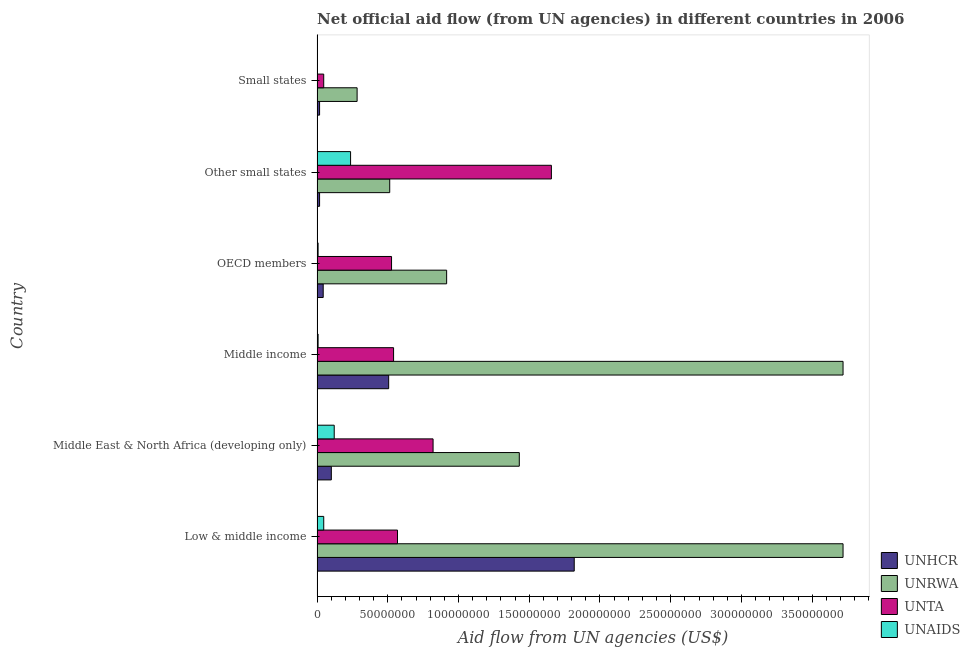How many groups of bars are there?
Keep it short and to the point. 6. Are the number of bars per tick equal to the number of legend labels?
Keep it short and to the point. Yes. How many bars are there on the 2nd tick from the bottom?
Your response must be concise. 4. What is the label of the 1st group of bars from the top?
Provide a short and direct response. Small states. What is the amount of aid given by unta in Small states?
Your answer should be very brief. 4.71e+06. Across all countries, what is the maximum amount of aid given by unhcr?
Provide a short and direct response. 1.82e+08. Across all countries, what is the minimum amount of aid given by unrwa?
Provide a succinct answer. 2.83e+07. In which country was the amount of aid given by unta maximum?
Make the answer very short. Other small states. In which country was the amount of aid given by unta minimum?
Your response must be concise. Small states. What is the total amount of aid given by unhcr in the graph?
Make the answer very short. 2.50e+08. What is the difference between the amount of aid given by unrwa in Low & middle income and that in Other small states?
Ensure brevity in your answer.  3.20e+08. What is the difference between the amount of aid given by unta in Middle income and the amount of aid given by unaids in Middle East & North Africa (developing only)?
Your answer should be very brief. 4.20e+07. What is the average amount of aid given by unta per country?
Provide a short and direct response. 6.93e+07. What is the difference between the amount of aid given by unhcr and amount of aid given by unaids in Low & middle income?
Keep it short and to the point. 1.77e+08. In how many countries, is the amount of aid given by unrwa greater than 170000000 US$?
Offer a terse response. 2. What is the ratio of the amount of aid given by unhcr in Low & middle income to that in OECD members?
Keep it short and to the point. 41.79. What is the difference between the highest and the second highest amount of aid given by unta?
Ensure brevity in your answer.  8.36e+07. What is the difference between the highest and the lowest amount of aid given by unta?
Offer a terse response. 1.61e+08. In how many countries, is the amount of aid given by unhcr greater than the average amount of aid given by unhcr taken over all countries?
Your answer should be compact. 2. Is the sum of the amount of aid given by unta in Middle East & North Africa (developing only) and Middle income greater than the maximum amount of aid given by unaids across all countries?
Provide a short and direct response. Yes. What does the 4th bar from the top in OECD members represents?
Make the answer very short. UNHCR. What does the 4th bar from the bottom in OECD members represents?
Your response must be concise. UNAIDS. Is it the case that in every country, the sum of the amount of aid given by unhcr and amount of aid given by unrwa is greater than the amount of aid given by unta?
Make the answer very short. No. How many bars are there?
Give a very brief answer. 24. Are all the bars in the graph horizontal?
Provide a succinct answer. Yes. How many countries are there in the graph?
Offer a very short reply. 6. Does the graph contain any zero values?
Provide a succinct answer. No. Does the graph contain grids?
Keep it short and to the point. No. What is the title of the graph?
Your answer should be very brief. Net official aid flow (from UN agencies) in different countries in 2006. Does "Denmark" appear as one of the legend labels in the graph?
Keep it short and to the point. No. What is the label or title of the X-axis?
Make the answer very short. Aid flow from UN agencies (US$). What is the Aid flow from UN agencies (US$) of UNHCR in Low & middle income?
Offer a terse response. 1.82e+08. What is the Aid flow from UN agencies (US$) in UNRWA in Low & middle income?
Provide a short and direct response. 3.72e+08. What is the Aid flow from UN agencies (US$) of UNTA in Low & middle income?
Keep it short and to the point. 5.69e+07. What is the Aid flow from UN agencies (US$) of UNAIDS in Low & middle income?
Offer a very short reply. 4.72e+06. What is the Aid flow from UN agencies (US$) of UNHCR in Middle East & North Africa (developing only)?
Ensure brevity in your answer.  1.01e+07. What is the Aid flow from UN agencies (US$) of UNRWA in Middle East & North Africa (developing only)?
Offer a terse response. 1.43e+08. What is the Aid flow from UN agencies (US$) of UNTA in Middle East & North Africa (developing only)?
Your answer should be very brief. 8.20e+07. What is the Aid flow from UN agencies (US$) of UNAIDS in Middle East & North Africa (developing only)?
Provide a short and direct response. 1.21e+07. What is the Aid flow from UN agencies (US$) of UNHCR in Middle income?
Make the answer very short. 5.06e+07. What is the Aid flow from UN agencies (US$) of UNRWA in Middle income?
Offer a very short reply. 3.72e+08. What is the Aid flow from UN agencies (US$) of UNTA in Middle income?
Make the answer very short. 5.41e+07. What is the Aid flow from UN agencies (US$) of UNAIDS in Middle income?
Make the answer very short. 7.40e+05. What is the Aid flow from UN agencies (US$) of UNHCR in OECD members?
Your response must be concise. 4.35e+06. What is the Aid flow from UN agencies (US$) in UNRWA in OECD members?
Ensure brevity in your answer.  9.16e+07. What is the Aid flow from UN agencies (US$) in UNTA in OECD members?
Give a very brief answer. 5.27e+07. What is the Aid flow from UN agencies (US$) in UNAIDS in OECD members?
Make the answer very short. 7.40e+05. What is the Aid flow from UN agencies (US$) in UNHCR in Other small states?
Provide a succinct answer. 1.78e+06. What is the Aid flow from UN agencies (US$) of UNRWA in Other small states?
Give a very brief answer. 5.14e+07. What is the Aid flow from UN agencies (US$) of UNTA in Other small states?
Offer a very short reply. 1.66e+08. What is the Aid flow from UN agencies (US$) of UNAIDS in Other small states?
Provide a succinct answer. 2.37e+07. What is the Aid flow from UN agencies (US$) in UNHCR in Small states?
Offer a very short reply. 1.78e+06. What is the Aid flow from UN agencies (US$) in UNRWA in Small states?
Keep it short and to the point. 2.83e+07. What is the Aid flow from UN agencies (US$) of UNTA in Small states?
Your answer should be compact. 4.71e+06. Across all countries, what is the maximum Aid flow from UN agencies (US$) in UNHCR?
Keep it short and to the point. 1.82e+08. Across all countries, what is the maximum Aid flow from UN agencies (US$) in UNRWA?
Give a very brief answer. 3.72e+08. Across all countries, what is the maximum Aid flow from UN agencies (US$) of UNTA?
Offer a very short reply. 1.66e+08. Across all countries, what is the maximum Aid flow from UN agencies (US$) of UNAIDS?
Offer a very short reply. 2.37e+07. Across all countries, what is the minimum Aid flow from UN agencies (US$) in UNHCR?
Ensure brevity in your answer.  1.78e+06. Across all countries, what is the minimum Aid flow from UN agencies (US$) in UNRWA?
Make the answer very short. 2.83e+07. Across all countries, what is the minimum Aid flow from UN agencies (US$) of UNTA?
Ensure brevity in your answer.  4.71e+06. What is the total Aid flow from UN agencies (US$) of UNHCR in the graph?
Keep it short and to the point. 2.50e+08. What is the total Aid flow from UN agencies (US$) in UNRWA in the graph?
Offer a very short reply. 1.06e+09. What is the total Aid flow from UN agencies (US$) of UNTA in the graph?
Give a very brief answer. 4.16e+08. What is the total Aid flow from UN agencies (US$) in UNAIDS in the graph?
Offer a very short reply. 4.23e+07. What is the difference between the Aid flow from UN agencies (US$) of UNHCR in Low & middle income and that in Middle East & North Africa (developing only)?
Provide a short and direct response. 1.72e+08. What is the difference between the Aid flow from UN agencies (US$) of UNRWA in Low & middle income and that in Middle East & North Africa (developing only)?
Provide a succinct answer. 2.29e+08. What is the difference between the Aid flow from UN agencies (US$) of UNTA in Low & middle income and that in Middle East & North Africa (developing only)?
Keep it short and to the point. -2.51e+07. What is the difference between the Aid flow from UN agencies (US$) of UNAIDS in Low & middle income and that in Middle East & North Africa (developing only)?
Ensure brevity in your answer.  -7.41e+06. What is the difference between the Aid flow from UN agencies (US$) in UNHCR in Low & middle income and that in Middle income?
Ensure brevity in your answer.  1.31e+08. What is the difference between the Aid flow from UN agencies (US$) of UNRWA in Low & middle income and that in Middle income?
Provide a succinct answer. 0. What is the difference between the Aid flow from UN agencies (US$) in UNTA in Low & middle income and that in Middle income?
Offer a very short reply. 2.78e+06. What is the difference between the Aid flow from UN agencies (US$) of UNAIDS in Low & middle income and that in Middle income?
Make the answer very short. 3.98e+06. What is the difference between the Aid flow from UN agencies (US$) of UNHCR in Low & middle income and that in OECD members?
Ensure brevity in your answer.  1.77e+08. What is the difference between the Aid flow from UN agencies (US$) of UNRWA in Low & middle income and that in OECD members?
Offer a terse response. 2.80e+08. What is the difference between the Aid flow from UN agencies (US$) in UNTA in Low & middle income and that in OECD members?
Ensure brevity in your answer.  4.21e+06. What is the difference between the Aid flow from UN agencies (US$) of UNAIDS in Low & middle income and that in OECD members?
Make the answer very short. 3.98e+06. What is the difference between the Aid flow from UN agencies (US$) in UNHCR in Low & middle income and that in Other small states?
Provide a succinct answer. 1.80e+08. What is the difference between the Aid flow from UN agencies (US$) in UNRWA in Low & middle income and that in Other small states?
Provide a succinct answer. 3.20e+08. What is the difference between the Aid flow from UN agencies (US$) in UNTA in Low & middle income and that in Other small states?
Your answer should be very brief. -1.09e+08. What is the difference between the Aid flow from UN agencies (US$) in UNAIDS in Low & middle income and that in Other small states?
Offer a very short reply. -1.90e+07. What is the difference between the Aid flow from UN agencies (US$) of UNHCR in Low & middle income and that in Small states?
Your answer should be very brief. 1.80e+08. What is the difference between the Aid flow from UN agencies (US$) of UNRWA in Low & middle income and that in Small states?
Your response must be concise. 3.43e+08. What is the difference between the Aid flow from UN agencies (US$) in UNTA in Low & middle income and that in Small states?
Your response must be concise. 5.22e+07. What is the difference between the Aid flow from UN agencies (US$) in UNAIDS in Low & middle income and that in Small states?
Provide a succinct answer. 4.46e+06. What is the difference between the Aid flow from UN agencies (US$) in UNHCR in Middle East & North Africa (developing only) and that in Middle income?
Provide a short and direct response. -4.05e+07. What is the difference between the Aid flow from UN agencies (US$) of UNRWA in Middle East & North Africa (developing only) and that in Middle income?
Ensure brevity in your answer.  -2.29e+08. What is the difference between the Aid flow from UN agencies (US$) in UNTA in Middle East & North Africa (developing only) and that in Middle income?
Offer a terse response. 2.79e+07. What is the difference between the Aid flow from UN agencies (US$) of UNAIDS in Middle East & North Africa (developing only) and that in Middle income?
Your response must be concise. 1.14e+07. What is the difference between the Aid flow from UN agencies (US$) of UNHCR in Middle East & North Africa (developing only) and that in OECD members?
Offer a terse response. 5.74e+06. What is the difference between the Aid flow from UN agencies (US$) of UNRWA in Middle East & North Africa (developing only) and that in OECD members?
Offer a very short reply. 5.14e+07. What is the difference between the Aid flow from UN agencies (US$) of UNTA in Middle East & North Africa (developing only) and that in OECD members?
Your answer should be compact. 2.94e+07. What is the difference between the Aid flow from UN agencies (US$) in UNAIDS in Middle East & North Africa (developing only) and that in OECD members?
Your answer should be compact. 1.14e+07. What is the difference between the Aid flow from UN agencies (US$) of UNHCR in Middle East & North Africa (developing only) and that in Other small states?
Make the answer very short. 8.31e+06. What is the difference between the Aid flow from UN agencies (US$) of UNRWA in Middle East & North Africa (developing only) and that in Other small states?
Make the answer very short. 9.16e+07. What is the difference between the Aid flow from UN agencies (US$) in UNTA in Middle East & North Africa (developing only) and that in Other small states?
Offer a very short reply. -8.36e+07. What is the difference between the Aid flow from UN agencies (US$) of UNAIDS in Middle East & North Africa (developing only) and that in Other small states?
Make the answer very short. -1.16e+07. What is the difference between the Aid flow from UN agencies (US$) in UNHCR in Middle East & North Africa (developing only) and that in Small states?
Your answer should be very brief. 8.31e+06. What is the difference between the Aid flow from UN agencies (US$) in UNRWA in Middle East & North Africa (developing only) and that in Small states?
Offer a very short reply. 1.15e+08. What is the difference between the Aid flow from UN agencies (US$) of UNTA in Middle East & North Africa (developing only) and that in Small states?
Provide a short and direct response. 7.73e+07. What is the difference between the Aid flow from UN agencies (US$) of UNAIDS in Middle East & North Africa (developing only) and that in Small states?
Offer a terse response. 1.19e+07. What is the difference between the Aid flow from UN agencies (US$) in UNHCR in Middle income and that in OECD members?
Provide a short and direct response. 4.63e+07. What is the difference between the Aid flow from UN agencies (US$) in UNRWA in Middle income and that in OECD members?
Provide a short and direct response. 2.80e+08. What is the difference between the Aid flow from UN agencies (US$) of UNTA in Middle income and that in OECD members?
Make the answer very short. 1.43e+06. What is the difference between the Aid flow from UN agencies (US$) of UNAIDS in Middle income and that in OECD members?
Provide a succinct answer. 0. What is the difference between the Aid flow from UN agencies (US$) in UNHCR in Middle income and that in Other small states?
Your answer should be very brief. 4.88e+07. What is the difference between the Aid flow from UN agencies (US$) in UNRWA in Middle income and that in Other small states?
Make the answer very short. 3.20e+08. What is the difference between the Aid flow from UN agencies (US$) in UNTA in Middle income and that in Other small states?
Your answer should be very brief. -1.12e+08. What is the difference between the Aid flow from UN agencies (US$) of UNAIDS in Middle income and that in Other small states?
Keep it short and to the point. -2.30e+07. What is the difference between the Aid flow from UN agencies (US$) of UNHCR in Middle income and that in Small states?
Your answer should be very brief. 4.88e+07. What is the difference between the Aid flow from UN agencies (US$) of UNRWA in Middle income and that in Small states?
Provide a short and direct response. 3.43e+08. What is the difference between the Aid flow from UN agencies (US$) in UNTA in Middle income and that in Small states?
Your response must be concise. 4.94e+07. What is the difference between the Aid flow from UN agencies (US$) of UNHCR in OECD members and that in Other small states?
Provide a short and direct response. 2.57e+06. What is the difference between the Aid flow from UN agencies (US$) in UNRWA in OECD members and that in Other small states?
Your answer should be very brief. 4.02e+07. What is the difference between the Aid flow from UN agencies (US$) of UNTA in OECD members and that in Other small states?
Your answer should be very brief. -1.13e+08. What is the difference between the Aid flow from UN agencies (US$) in UNAIDS in OECD members and that in Other small states?
Offer a very short reply. -2.30e+07. What is the difference between the Aid flow from UN agencies (US$) in UNHCR in OECD members and that in Small states?
Keep it short and to the point. 2.57e+06. What is the difference between the Aid flow from UN agencies (US$) in UNRWA in OECD members and that in Small states?
Provide a succinct answer. 6.33e+07. What is the difference between the Aid flow from UN agencies (US$) of UNTA in OECD members and that in Small states?
Your answer should be very brief. 4.80e+07. What is the difference between the Aid flow from UN agencies (US$) of UNAIDS in OECD members and that in Small states?
Provide a short and direct response. 4.80e+05. What is the difference between the Aid flow from UN agencies (US$) of UNRWA in Other small states and that in Small states?
Your answer should be compact. 2.30e+07. What is the difference between the Aid flow from UN agencies (US$) in UNTA in Other small states and that in Small states?
Your answer should be compact. 1.61e+08. What is the difference between the Aid flow from UN agencies (US$) in UNAIDS in Other small states and that in Small states?
Make the answer very short. 2.34e+07. What is the difference between the Aid flow from UN agencies (US$) of UNHCR in Low & middle income and the Aid flow from UN agencies (US$) of UNRWA in Middle East & North Africa (developing only)?
Your response must be concise. 3.88e+07. What is the difference between the Aid flow from UN agencies (US$) in UNHCR in Low & middle income and the Aid flow from UN agencies (US$) in UNTA in Middle East & North Africa (developing only)?
Provide a succinct answer. 9.98e+07. What is the difference between the Aid flow from UN agencies (US$) in UNHCR in Low & middle income and the Aid flow from UN agencies (US$) in UNAIDS in Middle East & North Africa (developing only)?
Your answer should be compact. 1.70e+08. What is the difference between the Aid flow from UN agencies (US$) in UNRWA in Low & middle income and the Aid flow from UN agencies (US$) in UNTA in Middle East & North Africa (developing only)?
Offer a very short reply. 2.90e+08. What is the difference between the Aid flow from UN agencies (US$) in UNRWA in Low & middle income and the Aid flow from UN agencies (US$) in UNAIDS in Middle East & North Africa (developing only)?
Provide a succinct answer. 3.60e+08. What is the difference between the Aid flow from UN agencies (US$) of UNTA in Low & middle income and the Aid flow from UN agencies (US$) of UNAIDS in Middle East & North Africa (developing only)?
Give a very brief answer. 4.47e+07. What is the difference between the Aid flow from UN agencies (US$) in UNHCR in Low & middle income and the Aid flow from UN agencies (US$) in UNRWA in Middle income?
Give a very brief answer. -1.90e+08. What is the difference between the Aid flow from UN agencies (US$) in UNHCR in Low & middle income and the Aid flow from UN agencies (US$) in UNTA in Middle income?
Your answer should be compact. 1.28e+08. What is the difference between the Aid flow from UN agencies (US$) in UNHCR in Low & middle income and the Aid flow from UN agencies (US$) in UNAIDS in Middle income?
Your response must be concise. 1.81e+08. What is the difference between the Aid flow from UN agencies (US$) of UNRWA in Low & middle income and the Aid flow from UN agencies (US$) of UNTA in Middle income?
Your response must be concise. 3.18e+08. What is the difference between the Aid flow from UN agencies (US$) in UNRWA in Low & middle income and the Aid flow from UN agencies (US$) in UNAIDS in Middle income?
Ensure brevity in your answer.  3.71e+08. What is the difference between the Aid flow from UN agencies (US$) of UNTA in Low & middle income and the Aid flow from UN agencies (US$) of UNAIDS in Middle income?
Your answer should be very brief. 5.61e+07. What is the difference between the Aid flow from UN agencies (US$) in UNHCR in Low & middle income and the Aid flow from UN agencies (US$) in UNRWA in OECD members?
Offer a terse response. 9.02e+07. What is the difference between the Aid flow from UN agencies (US$) of UNHCR in Low & middle income and the Aid flow from UN agencies (US$) of UNTA in OECD members?
Ensure brevity in your answer.  1.29e+08. What is the difference between the Aid flow from UN agencies (US$) in UNHCR in Low & middle income and the Aid flow from UN agencies (US$) in UNAIDS in OECD members?
Make the answer very short. 1.81e+08. What is the difference between the Aid flow from UN agencies (US$) in UNRWA in Low & middle income and the Aid flow from UN agencies (US$) in UNTA in OECD members?
Give a very brief answer. 3.19e+08. What is the difference between the Aid flow from UN agencies (US$) of UNRWA in Low & middle income and the Aid flow from UN agencies (US$) of UNAIDS in OECD members?
Your answer should be very brief. 3.71e+08. What is the difference between the Aid flow from UN agencies (US$) of UNTA in Low & middle income and the Aid flow from UN agencies (US$) of UNAIDS in OECD members?
Provide a succinct answer. 5.61e+07. What is the difference between the Aid flow from UN agencies (US$) in UNHCR in Low & middle income and the Aid flow from UN agencies (US$) in UNRWA in Other small states?
Give a very brief answer. 1.30e+08. What is the difference between the Aid flow from UN agencies (US$) in UNHCR in Low & middle income and the Aid flow from UN agencies (US$) in UNTA in Other small states?
Your answer should be compact. 1.61e+07. What is the difference between the Aid flow from UN agencies (US$) of UNHCR in Low & middle income and the Aid flow from UN agencies (US$) of UNAIDS in Other small states?
Give a very brief answer. 1.58e+08. What is the difference between the Aid flow from UN agencies (US$) of UNRWA in Low & middle income and the Aid flow from UN agencies (US$) of UNTA in Other small states?
Ensure brevity in your answer.  2.06e+08. What is the difference between the Aid flow from UN agencies (US$) of UNRWA in Low & middle income and the Aid flow from UN agencies (US$) of UNAIDS in Other small states?
Make the answer very short. 3.48e+08. What is the difference between the Aid flow from UN agencies (US$) in UNTA in Low & middle income and the Aid flow from UN agencies (US$) in UNAIDS in Other small states?
Ensure brevity in your answer.  3.32e+07. What is the difference between the Aid flow from UN agencies (US$) of UNHCR in Low & middle income and the Aid flow from UN agencies (US$) of UNRWA in Small states?
Your response must be concise. 1.53e+08. What is the difference between the Aid flow from UN agencies (US$) in UNHCR in Low & middle income and the Aid flow from UN agencies (US$) in UNTA in Small states?
Your response must be concise. 1.77e+08. What is the difference between the Aid flow from UN agencies (US$) in UNHCR in Low & middle income and the Aid flow from UN agencies (US$) in UNAIDS in Small states?
Offer a terse response. 1.82e+08. What is the difference between the Aid flow from UN agencies (US$) of UNRWA in Low & middle income and the Aid flow from UN agencies (US$) of UNTA in Small states?
Offer a very short reply. 3.67e+08. What is the difference between the Aid flow from UN agencies (US$) of UNRWA in Low & middle income and the Aid flow from UN agencies (US$) of UNAIDS in Small states?
Keep it short and to the point. 3.72e+08. What is the difference between the Aid flow from UN agencies (US$) in UNTA in Low & middle income and the Aid flow from UN agencies (US$) in UNAIDS in Small states?
Make the answer very short. 5.66e+07. What is the difference between the Aid flow from UN agencies (US$) of UNHCR in Middle East & North Africa (developing only) and the Aid flow from UN agencies (US$) of UNRWA in Middle income?
Your answer should be very brief. -3.62e+08. What is the difference between the Aid flow from UN agencies (US$) of UNHCR in Middle East & North Africa (developing only) and the Aid flow from UN agencies (US$) of UNTA in Middle income?
Provide a short and direct response. -4.40e+07. What is the difference between the Aid flow from UN agencies (US$) of UNHCR in Middle East & North Africa (developing only) and the Aid flow from UN agencies (US$) of UNAIDS in Middle income?
Make the answer very short. 9.35e+06. What is the difference between the Aid flow from UN agencies (US$) in UNRWA in Middle East & North Africa (developing only) and the Aid flow from UN agencies (US$) in UNTA in Middle income?
Give a very brief answer. 8.89e+07. What is the difference between the Aid flow from UN agencies (US$) in UNRWA in Middle East & North Africa (developing only) and the Aid flow from UN agencies (US$) in UNAIDS in Middle income?
Offer a terse response. 1.42e+08. What is the difference between the Aid flow from UN agencies (US$) of UNTA in Middle East & North Africa (developing only) and the Aid flow from UN agencies (US$) of UNAIDS in Middle income?
Ensure brevity in your answer.  8.13e+07. What is the difference between the Aid flow from UN agencies (US$) in UNHCR in Middle East & North Africa (developing only) and the Aid flow from UN agencies (US$) in UNRWA in OECD members?
Give a very brief answer. -8.15e+07. What is the difference between the Aid flow from UN agencies (US$) in UNHCR in Middle East & North Africa (developing only) and the Aid flow from UN agencies (US$) in UNTA in OECD members?
Provide a succinct answer. -4.26e+07. What is the difference between the Aid flow from UN agencies (US$) of UNHCR in Middle East & North Africa (developing only) and the Aid flow from UN agencies (US$) of UNAIDS in OECD members?
Your answer should be compact. 9.35e+06. What is the difference between the Aid flow from UN agencies (US$) of UNRWA in Middle East & North Africa (developing only) and the Aid flow from UN agencies (US$) of UNTA in OECD members?
Your answer should be very brief. 9.03e+07. What is the difference between the Aid flow from UN agencies (US$) in UNRWA in Middle East & North Africa (developing only) and the Aid flow from UN agencies (US$) in UNAIDS in OECD members?
Your response must be concise. 1.42e+08. What is the difference between the Aid flow from UN agencies (US$) in UNTA in Middle East & North Africa (developing only) and the Aid flow from UN agencies (US$) in UNAIDS in OECD members?
Give a very brief answer. 8.13e+07. What is the difference between the Aid flow from UN agencies (US$) in UNHCR in Middle East & North Africa (developing only) and the Aid flow from UN agencies (US$) in UNRWA in Other small states?
Make the answer very short. -4.13e+07. What is the difference between the Aid flow from UN agencies (US$) in UNHCR in Middle East & North Africa (developing only) and the Aid flow from UN agencies (US$) in UNTA in Other small states?
Make the answer very short. -1.56e+08. What is the difference between the Aid flow from UN agencies (US$) in UNHCR in Middle East & North Africa (developing only) and the Aid flow from UN agencies (US$) in UNAIDS in Other small states?
Offer a very short reply. -1.36e+07. What is the difference between the Aid flow from UN agencies (US$) in UNRWA in Middle East & North Africa (developing only) and the Aid flow from UN agencies (US$) in UNTA in Other small states?
Provide a succinct answer. -2.27e+07. What is the difference between the Aid flow from UN agencies (US$) in UNRWA in Middle East & North Africa (developing only) and the Aid flow from UN agencies (US$) in UNAIDS in Other small states?
Make the answer very short. 1.19e+08. What is the difference between the Aid flow from UN agencies (US$) of UNTA in Middle East & North Africa (developing only) and the Aid flow from UN agencies (US$) of UNAIDS in Other small states?
Give a very brief answer. 5.83e+07. What is the difference between the Aid flow from UN agencies (US$) of UNHCR in Middle East & North Africa (developing only) and the Aid flow from UN agencies (US$) of UNRWA in Small states?
Offer a terse response. -1.82e+07. What is the difference between the Aid flow from UN agencies (US$) in UNHCR in Middle East & North Africa (developing only) and the Aid flow from UN agencies (US$) in UNTA in Small states?
Keep it short and to the point. 5.38e+06. What is the difference between the Aid flow from UN agencies (US$) in UNHCR in Middle East & North Africa (developing only) and the Aid flow from UN agencies (US$) in UNAIDS in Small states?
Ensure brevity in your answer.  9.83e+06. What is the difference between the Aid flow from UN agencies (US$) in UNRWA in Middle East & North Africa (developing only) and the Aid flow from UN agencies (US$) in UNTA in Small states?
Ensure brevity in your answer.  1.38e+08. What is the difference between the Aid flow from UN agencies (US$) of UNRWA in Middle East & North Africa (developing only) and the Aid flow from UN agencies (US$) of UNAIDS in Small states?
Ensure brevity in your answer.  1.43e+08. What is the difference between the Aid flow from UN agencies (US$) in UNTA in Middle East & North Africa (developing only) and the Aid flow from UN agencies (US$) in UNAIDS in Small states?
Offer a very short reply. 8.18e+07. What is the difference between the Aid flow from UN agencies (US$) of UNHCR in Middle income and the Aid flow from UN agencies (US$) of UNRWA in OECD members?
Provide a short and direct response. -4.10e+07. What is the difference between the Aid flow from UN agencies (US$) of UNHCR in Middle income and the Aid flow from UN agencies (US$) of UNTA in OECD members?
Ensure brevity in your answer.  -2.04e+06. What is the difference between the Aid flow from UN agencies (US$) of UNHCR in Middle income and the Aid flow from UN agencies (US$) of UNAIDS in OECD members?
Your answer should be very brief. 4.99e+07. What is the difference between the Aid flow from UN agencies (US$) in UNRWA in Middle income and the Aid flow from UN agencies (US$) in UNTA in OECD members?
Ensure brevity in your answer.  3.19e+08. What is the difference between the Aid flow from UN agencies (US$) of UNRWA in Middle income and the Aid flow from UN agencies (US$) of UNAIDS in OECD members?
Your response must be concise. 3.71e+08. What is the difference between the Aid flow from UN agencies (US$) of UNTA in Middle income and the Aid flow from UN agencies (US$) of UNAIDS in OECD members?
Your answer should be compact. 5.34e+07. What is the difference between the Aid flow from UN agencies (US$) in UNHCR in Middle income and the Aid flow from UN agencies (US$) in UNRWA in Other small states?
Provide a short and direct response. -7.40e+05. What is the difference between the Aid flow from UN agencies (US$) of UNHCR in Middle income and the Aid flow from UN agencies (US$) of UNTA in Other small states?
Make the answer very short. -1.15e+08. What is the difference between the Aid flow from UN agencies (US$) in UNHCR in Middle income and the Aid flow from UN agencies (US$) in UNAIDS in Other small states?
Ensure brevity in your answer.  2.69e+07. What is the difference between the Aid flow from UN agencies (US$) in UNRWA in Middle income and the Aid flow from UN agencies (US$) in UNTA in Other small states?
Provide a succinct answer. 2.06e+08. What is the difference between the Aid flow from UN agencies (US$) in UNRWA in Middle income and the Aid flow from UN agencies (US$) in UNAIDS in Other small states?
Offer a terse response. 3.48e+08. What is the difference between the Aid flow from UN agencies (US$) in UNTA in Middle income and the Aid flow from UN agencies (US$) in UNAIDS in Other small states?
Keep it short and to the point. 3.04e+07. What is the difference between the Aid flow from UN agencies (US$) in UNHCR in Middle income and the Aid flow from UN agencies (US$) in UNRWA in Small states?
Offer a very short reply. 2.23e+07. What is the difference between the Aid flow from UN agencies (US$) of UNHCR in Middle income and the Aid flow from UN agencies (US$) of UNTA in Small states?
Offer a terse response. 4.59e+07. What is the difference between the Aid flow from UN agencies (US$) of UNHCR in Middle income and the Aid flow from UN agencies (US$) of UNAIDS in Small states?
Provide a succinct answer. 5.04e+07. What is the difference between the Aid flow from UN agencies (US$) in UNRWA in Middle income and the Aid flow from UN agencies (US$) in UNTA in Small states?
Your answer should be compact. 3.67e+08. What is the difference between the Aid flow from UN agencies (US$) in UNRWA in Middle income and the Aid flow from UN agencies (US$) in UNAIDS in Small states?
Offer a very short reply. 3.72e+08. What is the difference between the Aid flow from UN agencies (US$) of UNTA in Middle income and the Aid flow from UN agencies (US$) of UNAIDS in Small states?
Offer a terse response. 5.38e+07. What is the difference between the Aid flow from UN agencies (US$) of UNHCR in OECD members and the Aid flow from UN agencies (US$) of UNRWA in Other small states?
Your response must be concise. -4.70e+07. What is the difference between the Aid flow from UN agencies (US$) of UNHCR in OECD members and the Aid flow from UN agencies (US$) of UNTA in Other small states?
Offer a very short reply. -1.61e+08. What is the difference between the Aid flow from UN agencies (US$) in UNHCR in OECD members and the Aid flow from UN agencies (US$) in UNAIDS in Other small states?
Your answer should be compact. -1.94e+07. What is the difference between the Aid flow from UN agencies (US$) of UNRWA in OECD members and the Aid flow from UN agencies (US$) of UNTA in Other small states?
Give a very brief answer. -7.40e+07. What is the difference between the Aid flow from UN agencies (US$) of UNRWA in OECD members and the Aid flow from UN agencies (US$) of UNAIDS in Other small states?
Ensure brevity in your answer.  6.79e+07. What is the difference between the Aid flow from UN agencies (US$) in UNTA in OECD members and the Aid flow from UN agencies (US$) in UNAIDS in Other small states?
Offer a terse response. 2.90e+07. What is the difference between the Aid flow from UN agencies (US$) in UNHCR in OECD members and the Aid flow from UN agencies (US$) in UNRWA in Small states?
Make the answer very short. -2.40e+07. What is the difference between the Aid flow from UN agencies (US$) of UNHCR in OECD members and the Aid flow from UN agencies (US$) of UNTA in Small states?
Keep it short and to the point. -3.60e+05. What is the difference between the Aid flow from UN agencies (US$) in UNHCR in OECD members and the Aid flow from UN agencies (US$) in UNAIDS in Small states?
Your response must be concise. 4.09e+06. What is the difference between the Aid flow from UN agencies (US$) in UNRWA in OECD members and the Aid flow from UN agencies (US$) in UNTA in Small states?
Offer a terse response. 8.69e+07. What is the difference between the Aid flow from UN agencies (US$) of UNRWA in OECD members and the Aid flow from UN agencies (US$) of UNAIDS in Small states?
Give a very brief answer. 9.13e+07. What is the difference between the Aid flow from UN agencies (US$) of UNTA in OECD members and the Aid flow from UN agencies (US$) of UNAIDS in Small states?
Offer a terse response. 5.24e+07. What is the difference between the Aid flow from UN agencies (US$) in UNHCR in Other small states and the Aid flow from UN agencies (US$) in UNRWA in Small states?
Your answer should be compact. -2.65e+07. What is the difference between the Aid flow from UN agencies (US$) of UNHCR in Other small states and the Aid flow from UN agencies (US$) of UNTA in Small states?
Offer a very short reply. -2.93e+06. What is the difference between the Aid flow from UN agencies (US$) in UNHCR in Other small states and the Aid flow from UN agencies (US$) in UNAIDS in Small states?
Make the answer very short. 1.52e+06. What is the difference between the Aid flow from UN agencies (US$) in UNRWA in Other small states and the Aid flow from UN agencies (US$) in UNTA in Small states?
Make the answer very short. 4.66e+07. What is the difference between the Aid flow from UN agencies (US$) in UNRWA in Other small states and the Aid flow from UN agencies (US$) in UNAIDS in Small states?
Provide a succinct answer. 5.11e+07. What is the difference between the Aid flow from UN agencies (US$) of UNTA in Other small states and the Aid flow from UN agencies (US$) of UNAIDS in Small states?
Provide a short and direct response. 1.65e+08. What is the average Aid flow from UN agencies (US$) in UNHCR per country?
Offer a very short reply. 4.17e+07. What is the average Aid flow from UN agencies (US$) of UNRWA per country?
Offer a terse response. 1.76e+08. What is the average Aid flow from UN agencies (US$) in UNTA per country?
Provide a short and direct response. 6.93e+07. What is the average Aid flow from UN agencies (US$) in UNAIDS per country?
Your response must be concise. 7.05e+06. What is the difference between the Aid flow from UN agencies (US$) in UNHCR and Aid flow from UN agencies (US$) in UNRWA in Low & middle income?
Provide a succinct answer. -1.90e+08. What is the difference between the Aid flow from UN agencies (US$) in UNHCR and Aid flow from UN agencies (US$) in UNTA in Low & middle income?
Your answer should be very brief. 1.25e+08. What is the difference between the Aid flow from UN agencies (US$) in UNHCR and Aid flow from UN agencies (US$) in UNAIDS in Low & middle income?
Your answer should be very brief. 1.77e+08. What is the difference between the Aid flow from UN agencies (US$) in UNRWA and Aid flow from UN agencies (US$) in UNTA in Low & middle income?
Your answer should be compact. 3.15e+08. What is the difference between the Aid flow from UN agencies (US$) in UNRWA and Aid flow from UN agencies (US$) in UNAIDS in Low & middle income?
Offer a very short reply. 3.67e+08. What is the difference between the Aid flow from UN agencies (US$) of UNTA and Aid flow from UN agencies (US$) of UNAIDS in Low & middle income?
Give a very brief answer. 5.22e+07. What is the difference between the Aid flow from UN agencies (US$) of UNHCR and Aid flow from UN agencies (US$) of UNRWA in Middle East & North Africa (developing only)?
Your response must be concise. -1.33e+08. What is the difference between the Aid flow from UN agencies (US$) of UNHCR and Aid flow from UN agencies (US$) of UNTA in Middle East & North Africa (developing only)?
Make the answer very short. -7.19e+07. What is the difference between the Aid flow from UN agencies (US$) of UNHCR and Aid flow from UN agencies (US$) of UNAIDS in Middle East & North Africa (developing only)?
Provide a short and direct response. -2.04e+06. What is the difference between the Aid flow from UN agencies (US$) of UNRWA and Aid flow from UN agencies (US$) of UNTA in Middle East & North Africa (developing only)?
Provide a short and direct response. 6.10e+07. What is the difference between the Aid flow from UN agencies (US$) in UNRWA and Aid flow from UN agencies (US$) in UNAIDS in Middle East & North Africa (developing only)?
Provide a short and direct response. 1.31e+08. What is the difference between the Aid flow from UN agencies (US$) in UNTA and Aid flow from UN agencies (US$) in UNAIDS in Middle East & North Africa (developing only)?
Your answer should be compact. 6.99e+07. What is the difference between the Aid flow from UN agencies (US$) of UNHCR and Aid flow from UN agencies (US$) of UNRWA in Middle income?
Offer a very short reply. -3.21e+08. What is the difference between the Aid flow from UN agencies (US$) of UNHCR and Aid flow from UN agencies (US$) of UNTA in Middle income?
Give a very brief answer. -3.47e+06. What is the difference between the Aid flow from UN agencies (US$) of UNHCR and Aid flow from UN agencies (US$) of UNAIDS in Middle income?
Make the answer very short. 4.99e+07. What is the difference between the Aid flow from UN agencies (US$) of UNRWA and Aid flow from UN agencies (US$) of UNTA in Middle income?
Provide a succinct answer. 3.18e+08. What is the difference between the Aid flow from UN agencies (US$) in UNRWA and Aid flow from UN agencies (US$) in UNAIDS in Middle income?
Give a very brief answer. 3.71e+08. What is the difference between the Aid flow from UN agencies (US$) of UNTA and Aid flow from UN agencies (US$) of UNAIDS in Middle income?
Your answer should be very brief. 5.34e+07. What is the difference between the Aid flow from UN agencies (US$) in UNHCR and Aid flow from UN agencies (US$) in UNRWA in OECD members?
Your response must be concise. -8.72e+07. What is the difference between the Aid flow from UN agencies (US$) of UNHCR and Aid flow from UN agencies (US$) of UNTA in OECD members?
Offer a terse response. -4.83e+07. What is the difference between the Aid flow from UN agencies (US$) of UNHCR and Aid flow from UN agencies (US$) of UNAIDS in OECD members?
Offer a very short reply. 3.61e+06. What is the difference between the Aid flow from UN agencies (US$) of UNRWA and Aid flow from UN agencies (US$) of UNTA in OECD members?
Your answer should be very brief. 3.89e+07. What is the difference between the Aid flow from UN agencies (US$) in UNRWA and Aid flow from UN agencies (US$) in UNAIDS in OECD members?
Make the answer very short. 9.09e+07. What is the difference between the Aid flow from UN agencies (US$) in UNTA and Aid flow from UN agencies (US$) in UNAIDS in OECD members?
Give a very brief answer. 5.19e+07. What is the difference between the Aid flow from UN agencies (US$) of UNHCR and Aid flow from UN agencies (US$) of UNRWA in Other small states?
Offer a terse response. -4.96e+07. What is the difference between the Aid flow from UN agencies (US$) of UNHCR and Aid flow from UN agencies (US$) of UNTA in Other small states?
Offer a terse response. -1.64e+08. What is the difference between the Aid flow from UN agencies (US$) in UNHCR and Aid flow from UN agencies (US$) in UNAIDS in Other small states?
Your answer should be compact. -2.19e+07. What is the difference between the Aid flow from UN agencies (US$) of UNRWA and Aid flow from UN agencies (US$) of UNTA in Other small states?
Your answer should be compact. -1.14e+08. What is the difference between the Aid flow from UN agencies (US$) in UNRWA and Aid flow from UN agencies (US$) in UNAIDS in Other small states?
Provide a succinct answer. 2.77e+07. What is the difference between the Aid flow from UN agencies (US$) in UNTA and Aid flow from UN agencies (US$) in UNAIDS in Other small states?
Your answer should be very brief. 1.42e+08. What is the difference between the Aid flow from UN agencies (US$) of UNHCR and Aid flow from UN agencies (US$) of UNRWA in Small states?
Give a very brief answer. -2.65e+07. What is the difference between the Aid flow from UN agencies (US$) in UNHCR and Aid flow from UN agencies (US$) in UNTA in Small states?
Ensure brevity in your answer.  -2.93e+06. What is the difference between the Aid flow from UN agencies (US$) of UNHCR and Aid flow from UN agencies (US$) of UNAIDS in Small states?
Offer a terse response. 1.52e+06. What is the difference between the Aid flow from UN agencies (US$) of UNRWA and Aid flow from UN agencies (US$) of UNTA in Small states?
Ensure brevity in your answer.  2.36e+07. What is the difference between the Aid flow from UN agencies (US$) of UNRWA and Aid flow from UN agencies (US$) of UNAIDS in Small states?
Give a very brief answer. 2.81e+07. What is the difference between the Aid flow from UN agencies (US$) of UNTA and Aid flow from UN agencies (US$) of UNAIDS in Small states?
Keep it short and to the point. 4.45e+06. What is the ratio of the Aid flow from UN agencies (US$) of UNHCR in Low & middle income to that in Middle East & North Africa (developing only)?
Your answer should be compact. 18.02. What is the ratio of the Aid flow from UN agencies (US$) of UNRWA in Low & middle income to that in Middle East & North Africa (developing only)?
Your answer should be compact. 2.6. What is the ratio of the Aid flow from UN agencies (US$) of UNTA in Low & middle income to that in Middle East & North Africa (developing only)?
Keep it short and to the point. 0.69. What is the ratio of the Aid flow from UN agencies (US$) of UNAIDS in Low & middle income to that in Middle East & North Africa (developing only)?
Provide a succinct answer. 0.39. What is the ratio of the Aid flow from UN agencies (US$) in UNHCR in Low & middle income to that in Middle income?
Ensure brevity in your answer.  3.59. What is the ratio of the Aid flow from UN agencies (US$) of UNRWA in Low & middle income to that in Middle income?
Keep it short and to the point. 1. What is the ratio of the Aid flow from UN agencies (US$) in UNTA in Low & middle income to that in Middle income?
Keep it short and to the point. 1.05. What is the ratio of the Aid flow from UN agencies (US$) in UNAIDS in Low & middle income to that in Middle income?
Make the answer very short. 6.38. What is the ratio of the Aid flow from UN agencies (US$) of UNHCR in Low & middle income to that in OECD members?
Offer a terse response. 41.79. What is the ratio of the Aid flow from UN agencies (US$) in UNRWA in Low & middle income to that in OECD members?
Your response must be concise. 4.06. What is the ratio of the Aid flow from UN agencies (US$) in UNTA in Low & middle income to that in OECD members?
Give a very brief answer. 1.08. What is the ratio of the Aid flow from UN agencies (US$) in UNAIDS in Low & middle income to that in OECD members?
Keep it short and to the point. 6.38. What is the ratio of the Aid flow from UN agencies (US$) in UNHCR in Low & middle income to that in Other small states?
Your answer should be very brief. 102.13. What is the ratio of the Aid flow from UN agencies (US$) in UNRWA in Low & middle income to that in Other small states?
Give a very brief answer. 7.24. What is the ratio of the Aid flow from UN agencies (US$) in UNTA in Low & middle income to that in Other small states?
Provide a short and direct response. 0.34. What is the ratio of the Aid flow from UN agencies (US$) in UNAIDS in Low & middle income to that in Other small states?
Keep it short and to the point. 0.2. What is the ratio of the Aid flow from UN agencies (US$) of UNHCR in Low & middle income to that in Small states?
Offer a very short reply. 102.13. What is the ratio of the Aid flow from UN agencies (US$) of UNRWA in Low & middle income to that in Small states?
Provide a short and direct response. 13.13. What is the ratio of the Aid flow from UN agencies (US$) of UNTA in Low & middle income to that in Small states?
Your answer should be compact. 12.07. What is the ratio of the Aid flow from UN agencies (US$) in UNAIDS in Low & middle income to that in Small states?
Make the answer very short. 18.15. What is the ratio of the Aid flow from UN agencies (US$) in UNHCR in Middle East & North Africa (developing only) to that in Middle income?
Your response must be concise. 0.2. What is the ratio of the Aid flow from UN agencies (US$) in UNRWA in Middle East & North Africa (developing only) to that in Middle income?
Make the answer very short. 0.38. What is the ratio of the Aid flow from UN agencies (US$) in UNTA in Middle East & North Africa (developing only) to that in Middle income?
Keep it short and to the point. 1.52. What is the ratio of the Aid flow from UN agencies (US$) in UNAIDS in Middle East & North Africa (developing only) to that in Middle income?
Provide a short and direct response. 16.39. What is the ratio of the Aid flow from UN agencies (US$) of UNHCR in Middle East & North Africa (developing only) to that in OECD members?
Make the answer very short. 2.32. What is the ratio of the Aid flow from UN agencies (US$) of UNRWA in Middle East & North Africa (developing only) to that in OECD members?
Give a very brief answer. 1.56. What is the ratio of the Aid flow from UN agencies (US$) in UNTA in Middle East & North Africa (developing only) to that in OECD members?
Offer a very short reply. 1.56. What is the ratio of the Aid flow from UN agencies (US$) of UNAIDS in Middle East & North Africa (developing only) to that in OECD members?
Give a very brief answer. 16.39. What is the ratio of the Aid flow from UN agencies (US$) in UNHCR in Middle East & North Africa (developing only) to that in Other small states?
Offer a very short reply. 5.67. What is the ratio of the Aid flow from UN agencies (US$) in UNRWA in Middle East & North Africa (developing only) to that in Other small states?
Your response must be concise. 2.78. What is the ratio of the Aid flow from UN agencies (US$) of UNTA in Middle East & North Africa (developing only) to that in Other small states?
Provide a short and direct response. 0.5. What is the ratio of the Aid flow from UN agencies (US$) of UNAIDS in Middle East & North Africa (developing only) to that in Other small states?
Provide a short and direct response. 0.51. What is the ratio of the Aid flow from UN agencies (US$) in UNHCR in Middle East & North Africa (developing only) to that in Small states?
Ensure brevity in your answer.  5.67. What is the ratio of the Aid flow from UN agencies (US$) in UNRWA in Middle East & North Africa (developing only) to that in Small states?
Your answer should be compact. 5.05. What is the ratio of the Aid flow from UN agencies (US$) in UNTA in Middle East & North Africa (developing only) to that in Small states?
Provide a succinct answer. 17.41. What is the ratio of the Aid flow from UN agencies (US$) in UNAIDS in Middle East & North Africa (developing only) to that in Small states?
Give a very brief answer. 46.65. What is the ratio of the Aid flow from UN agencies (US$) in UNHCR in Middle income to that in OECD members?
Your answer should be compact. 11.64. What is the ratio of the Aid flow from UN agencies (US$) in UNRWA in Middle income to that in OECD members?
Offer a terse response. 4.06. What is the ratio of the Aid flow from UN agencies (US$) in UNTA in Middle income to that in OECD members?
Your answer should be very brief. 1.03. What is the ratio of the Aid flow from UN agencies (US$) in UNAIDS in Middle income to that in OECD members?
Give a very brief answer. 1. What is the ratio of the Aid flow from UN agencies (US$) of UNHCR in Middle income to that in Other small states?
Your answer should be compact. 28.44. What is the ratio of the Aid flow from UN agencies (US$) in UNRWA in Middle income to that in Other small states?
Provide a short and direct response. 7.24. What is the ratio of the Aid flow from UN agencies (US$) of UNTA in Middle income to that in Other small states?
Offer a very short reply. 0.33. What is the ratio of the Aid flow from UN agencies (US$) of UNAIDS in Middle income to that in Other small states?
Your answer should be compact. 0.03. What is the ratio of the Aid flow from UN agencies (US$) in UNHCR in Middle income to that in Small states?
Provide a succinct answer. 28.44. What is the ratio of the Aid flow from UN agencies (US$) in UNRWA in Middle income to that in Small states?
Offer a terse response. 13.13. What is the ratio of the Aid flow from UN agencies (US$) in UNTA in Middle income to that in Small states?
Keep it short and to the point. 11.48. What is the ratio of the Aid flow from UN agencies (US$) of UNAIDS in Middle income to that in Small states?
Provide a succinct answer. 2.85. What is the ratio of the Aid flow from UN agencies (US$) in UNHCR in OECD members to that in Other small states?
Offer a very short reply. 2.44. What is the ratio of the Aid flow from UN agencies (US$) in UNRWA in OECD members to that in Other small states?
Your answer should be very brief. 1.78. What is the ratio of the Aid flow from UN agencies (US$) in UNTA in OECD members to that in Other small states?
Give a very brief answer. 0.32. What is the ratio of the Aid flow from UN agencies (US$) in UNAIDS in OECD members to that in Other small states?
Keep it short and to the point. 0.03. What is the ratio of the Aid flow from UN agencies (US$) of UNHCR in OECD members to that in Small states?
Offer a terse response. 2.44. What is the ratio of the Aid flow from UN agencies (US$) in UNRWA in OECD members to that in Small states?
Offer a very short reply. 3.23. What is the ratio of the Aid flow from UN agencies (US$) in UNTA in OECD members to that in Small states?
Provide a short and direct response. 11.18. What is the ratio of the Aid flow from UN agencies (US$) of UNAIDS in OECD members to that in Small states?
Provide a succinct answer. 2.85. What is the ratio of the Aid flow from UN agencies (US$) in UNRWA in Other small states to that in Small states?
Give a very brief answer. 1.81. What is the ratio of the Aid flow from UN agencies (US$) in UNTA in Other small states to that in Small states?
Offer a very short reply. 35.17. What is the ratio of the Aid flow from UN agencies (US$) of UNAIDS in Other small states to that in Small states?
Make the answer very short. 91.15. What is the difference between the highest and the second highest Aid flow from UN agencies (US$) of UNHCR?
Make the answer very short. 1.31e+08. What is the difference between the highest and the second highest Aid flow from UN agencies (US$) of UNTA?
Make the answer very short. 8.36e+07. What is the difference between the highest and the second highest Aid flow from UN agencies (US$) in UNAIDS?
Provide a short and direct response. 1.16e+07. What is the difference between the highest and the lowest Aid flow from UN agencies (US$) in UNHCR?
Your answer should be compact. 1.80e+08. What is the difference between the highest and the lowest Aid flow from UN agencies (US$) in UNRWA?
Offer a terse response. 3.43e+08. What is the difference between the highest and the lowest Aid flow from UN agencies (US$) in UNTA?
Offer a very short reply. 1.61e+08. What is the difference between the highest and the lowest Aid flow from UN agencies (US$) of UNAIDS?
Offer a very short reply. 2.34e+07. 